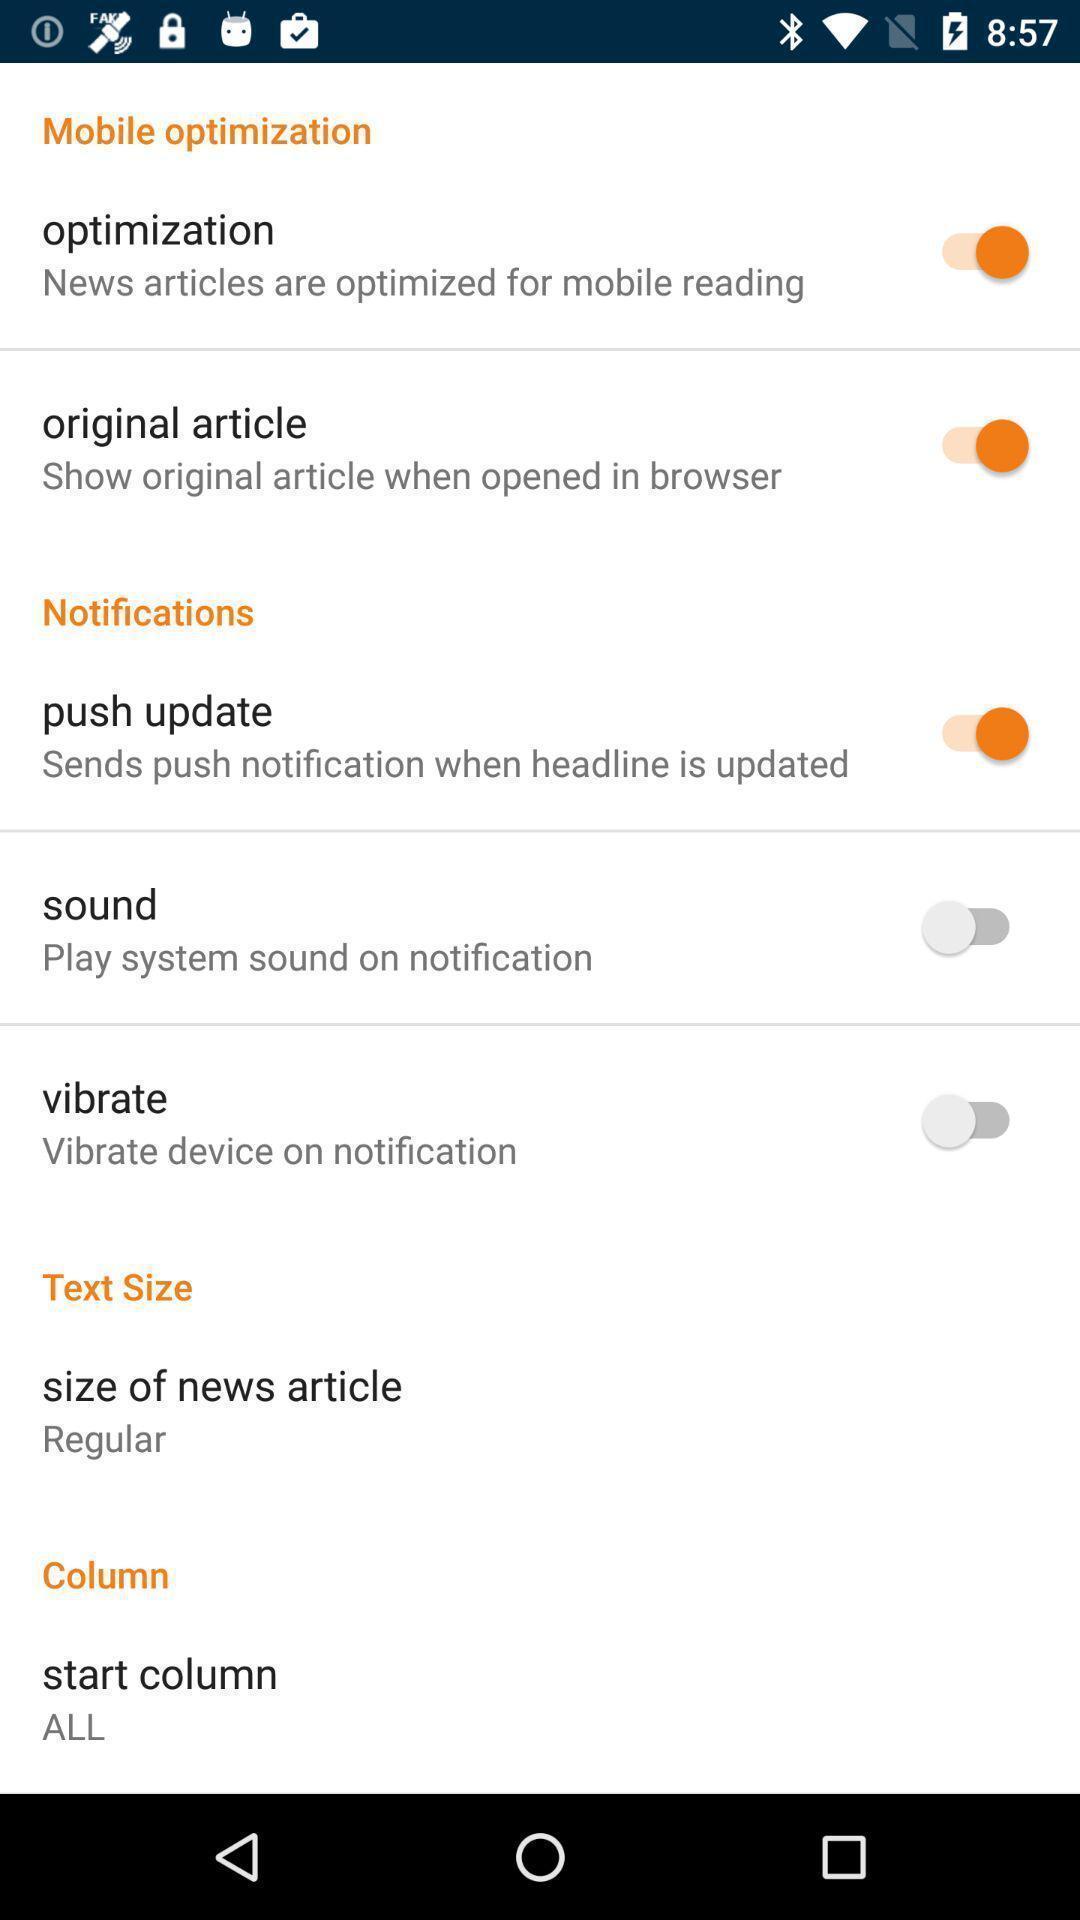Explain the elements present in this screenshot. Page showing variety of notification settings. 